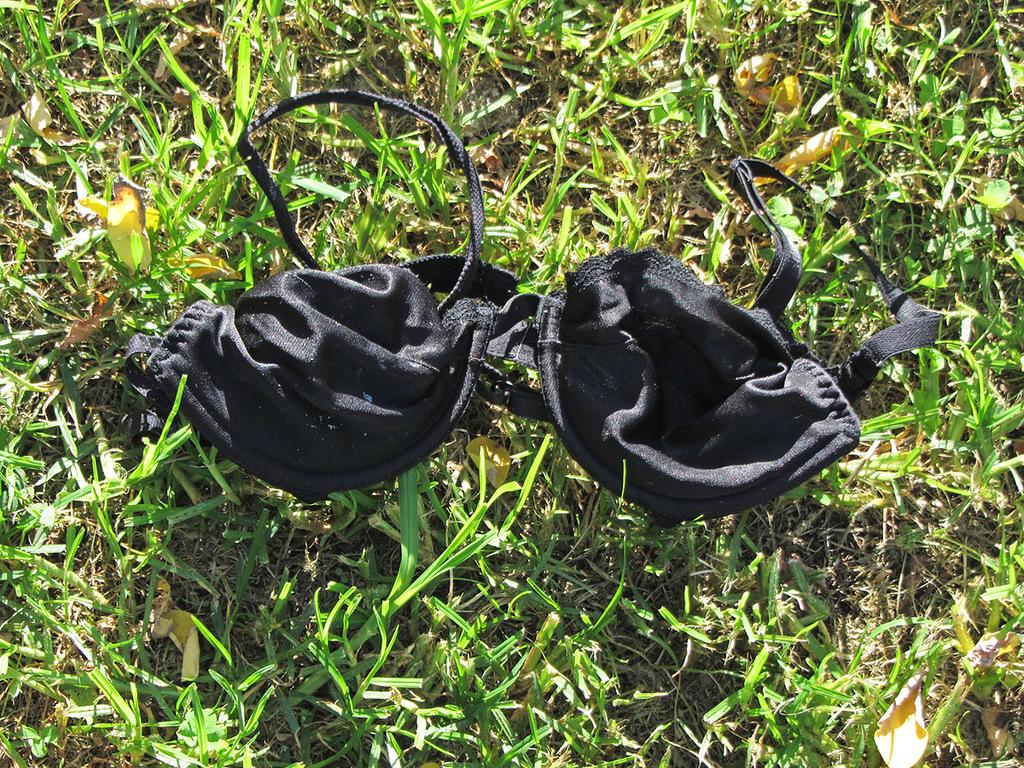What type of surface is visible in the image? There is a grass surface in the image. What is placed on the grass surface? There is a black color wear on the grass surface. What type of marble is visible on the grass surface in the image? There is no marble present on the grass surface in the image. What color is the dirt on the grass surface in the image? There is no dirt present on the grass surface in the image. 